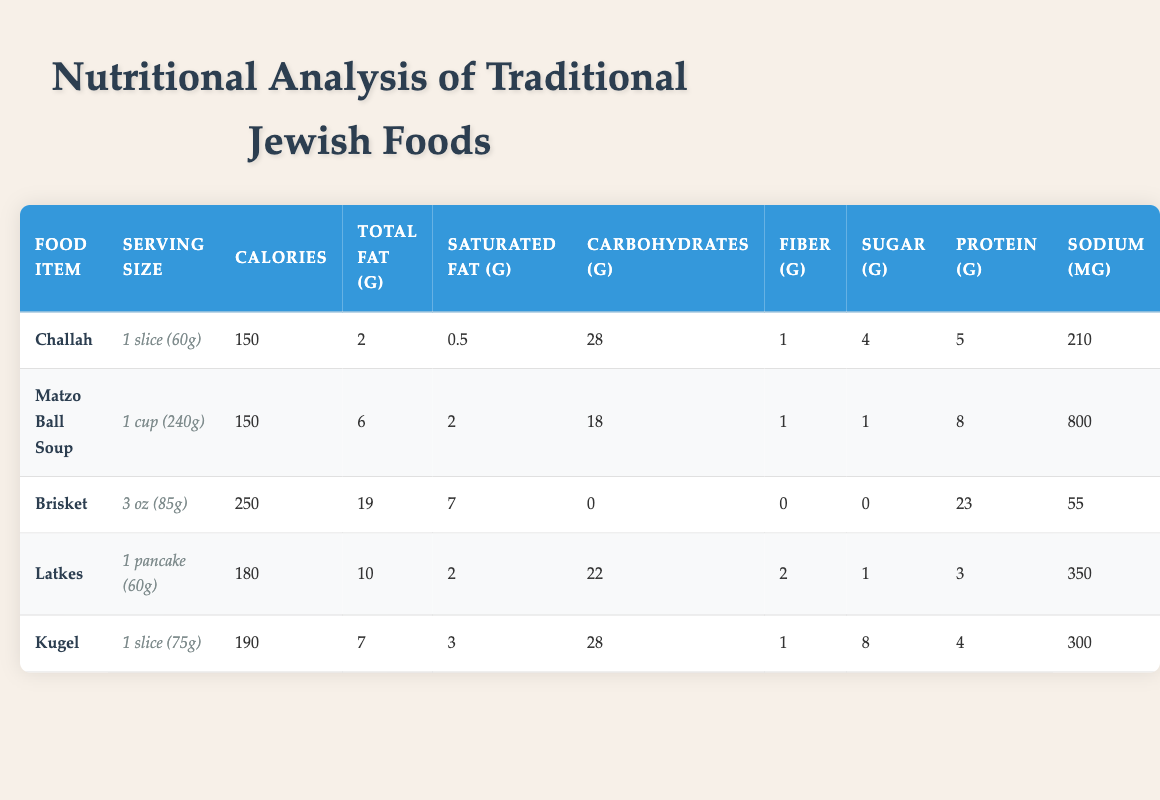What is the serving size of Kugel? The serving size of Kugel is listed in the table as "1 slice (75g)."
Answer: 1 slice (75g) Which food item has the highest sodium content? By examining the sodium content for each food item: Challah has 210 mg, Matzo Ball Soup has 800 mg, Brisket has 55 mg, Latkes has 350 mg, and Kugel has 300 mg. The highest value is from Matzo Ball Soup at 800 mg.
Answer: Matzo Ball Soup What is the total fat content in Latkes? Latkes has a total fat content listed as 10 g in the table.
Answer: 10 g Which food item has the least amount of carbohydrates? The carbohydrates for each food item are: Challah has 28 g, Matzo Ball Soup has 18 g, Brisket has 0 g, Latkes has 22 g, and Kugel has 28 g. Brisket has the least carbohydrates at 0 g.
Answer: Brisket What is the average calorie content of the traditional Jewish foods listed? To compute the average calories, sum the calorie counts: 150 (Challah) + 150 (Matzo Ball Soup) + 250 (Brisket) + 180 (Latkes) + 190 (Kugel) = 1020. There are 5 food items, so the average is 1020 / 5 = 204.
Answer: 204 Is the sugar content in Matzo Ball Soup higher than in Kugel? Matzo Ball Soup has 1 g of sugar, while Kugel has 8 g. Since 1 g is less than 8 g, the statement is false.
Answer: No How much more protein does Brisket have compared to Latkes? Brisket has 23 g of protein, while Latkes has 3 g. The difference is 23 g - 3 g = 20 g, meaning Brisket has 20 g more protein than Latkes.
Answer: 20 g What is the total amount of fiber in all five food items combined? The fiber content for each food item is: Challah has 1 g, Matzo Ball Soup has 1 g, Brisket has 0 g, Latkes has 2 g, and Kugel has 1 g. Adding these values gives 1 + 1 + 0 + 2 + 1 = 5 g of fiber in total.
Answer: 5 g Is Challah less calorific than Latkes? Challah has 150 calories, while Latkes has 180 calories. Since 150 is less than 180, the statement is true.
Answer: Yes 